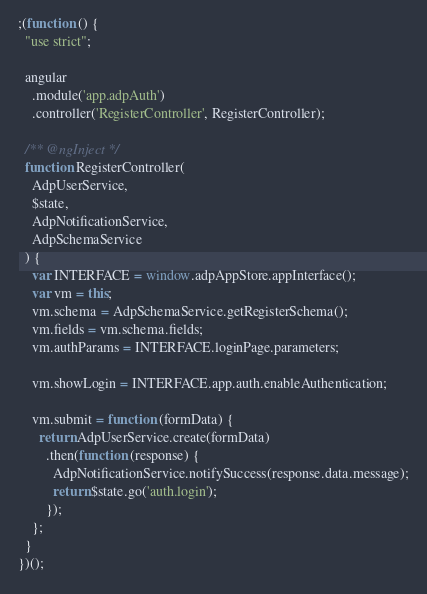<code> <loc_0><loc_0><loc_500><loc_500><_JavaScript_>;(function () {
  "use strict";

  angular
    .module('app.adpAuth')
    .controller('RegisterController', RegisterController);

  /** @ngInject */
  function RegisterController(
    AdpUserService,
    $state,
    AdpNotificationService,
    AdpSchemaService
  ) {
    var INTERFACE = window.adpAppStore.appInterface();
    var vm = this;
    vm.schema = AdpSchemaService.getRegisterSchema();
    vm.fields = vm.schema.fields;
    vm.authParams = INTERFACE.loginPage.parameters;

    vm.showLogin = INTERFACE.app.auth.enableAuthentication;

    vm.submit = function (formData) {
      return AdpUserService.create(formData)
        .then(function (response) {
          AdpNotificationService.notifySuccess(response.data.message);
          return $state.go('auth.login');
        });
    };
  }
})();</code> 